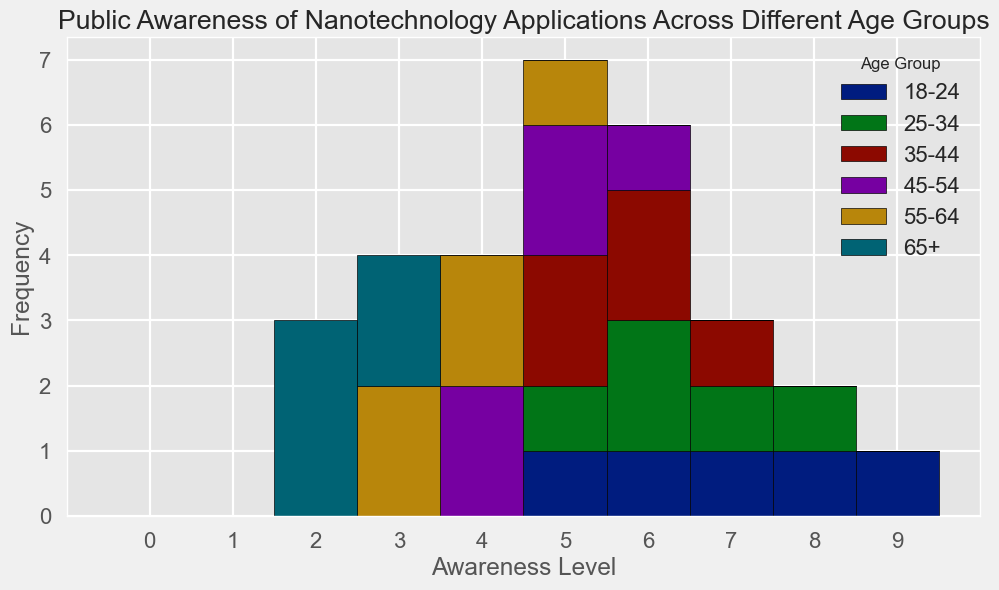What is the age group with the highest combined frequency for awareness levels 2 and 3? The age group with the highest combined frequency for awareness levels 2 and 3 can be determined by summing the frequencies of each level in all age groups. From the figure, the 65+ group has the highest combined frequency of 7 (2 at level 2 + 5 at level 3).
Answer: 65+ Which age group shows the highest level of public awareness on average? To find out which age group shows the highest level of public awareness on average, you calculate the average awareness level for each group. The 18-24 group has the highest average awareness level of (5+7+9+6+8)/5 = 7.
Answer: 18-24 What is the total number of people surveyed across all age groups? To get the total number of people surveyed, sum the frequencies across all age groups. The total is 5 (18-24) + 5 (25-34) + 5 (35-44) + 5 (45-54) + 5 (55-64) + 5 (65+) = 30.
Answer: 30 Do older age groups (55-64 and 65+) tend to have lower awareness levels compared to younger age groups (18-24 and 25-34)? Compare the distribution of awareness levels across the age groups. The older groups (55-64 and 65+) have higher frequencies at lower awareness levels (2-5), while younger groups (18-24 and 25-34) have higher frequencies at higher awareness levels (5-9). This suggests older age groups tend to have lower awareness levels.
Answer: Yes Which awareness level has the highest frequency in the 45-54 age group? By examining the histogram, the 45-54 age group has the highest frequency at the awareness level 5, with a count of 2.
Answer: 5 What is the combined frequency of awareness levels 4, 5, and 6 for the 35-44 age group? Identify the frequencies of levels 4, 5, and 6 for the 35-44 age group and sum them up. The combined frequency is 0 (level 4) + 2 (level 5) + 2 (level 6) = 4.
Answer: 4 Which age group has the least variation in awareness levels? Measure the spread of the histogram bars for each age group. The 65+ group has values only at levels 2 and 3, showing the least variation in awareness levels compared to other groups.
Answer: 65+ Are there more individuals with an awareness level greater than 6 in the 18-24 age group than in the 25-34 age group? Count the frequencies of awareness levels greater than 6 in both age groups. The 18-24 group has 2 (levels 7, 8, and 9) while the 25-34 group has 1 (level 8), so the 18-24 group has more individuals.
Answer: Yes What is the frequency of the lowest awareness level recorded in the survey? From the histogram, the lowest recorded awareness level is 2, which has a frequency of 3 in the 65+ age group.
Answer: 3 How does the frequency at awareness level 6 compare between age groups 25-34 and 45-54? The histogram shows that both age groups 25-34 and 45-54 have a frequency of 1 at awareness level 6.
Answer: Equal 